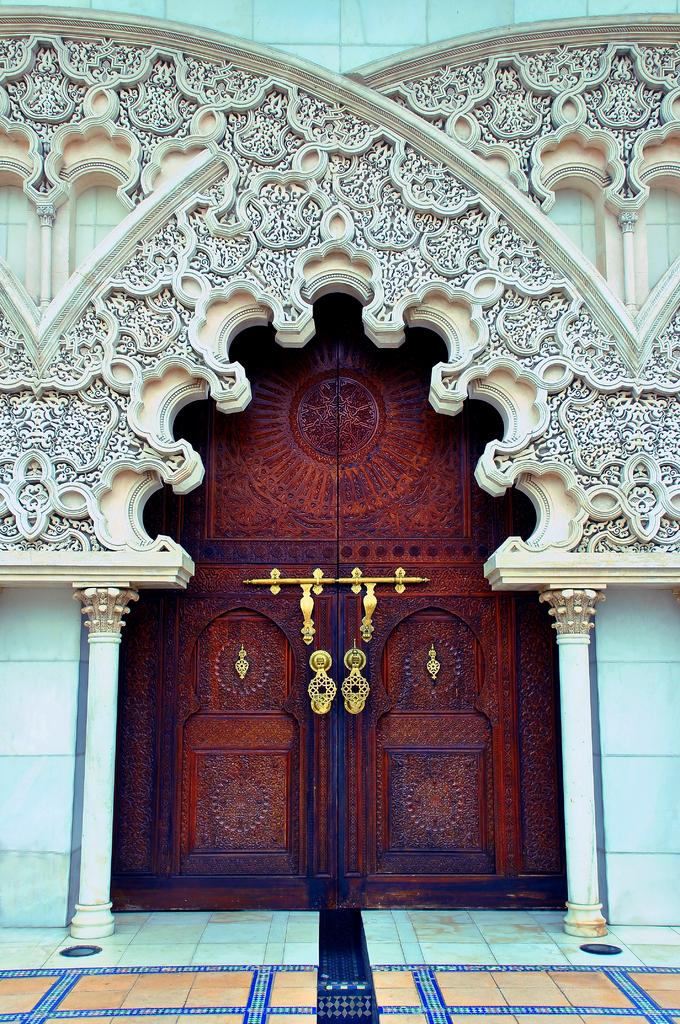What is the main structure in the center of the image? There is a building in the center of the image. What other architectural features can be seen in the image? There is a wall and pillars in the image. Can you describe the door in the image? The door in the image is brown in color. What else is present in the image besides the building, wall, and pillars? There are other objects in the image. What kind of design is on the wall in the image? There is a design on the wall in the image. What type of drum can be heard playing in the image? There is no drum present in the image, and therefore no sound can be heard. 